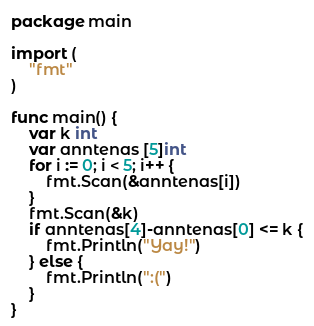<code> <loc_0><loc_0><loc_500><loc_500><_Go_>package main

import (
	"fmt"
)

func main() {
	var k int
	var anntenas [5]int
	for i := 0; i < 5; i++ {
		fmt.Scan(&anntenas[i])
	}
	fmt.Scan(&k)
	if anntenas[4]-anntenas[0] <= k {
		fmt.Println("Yay!")
	} else {
		fmt.Println(":(")
	}
}
</code> 